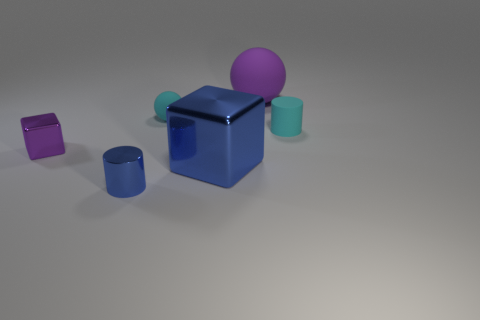Add 2 large purple matte balls. How many objects exist? 8 Subtract all blocks. How many objects are left? 4 Subtract all large blue objects. Subtract all blue matte balls. How many objects are left? 5 Add 4 tiny cyan cylinders. How many tiny cyan cylinders are left? 5 Add 2 large gray matte cubes. How many large gray matte cubes exist? 2 Subtract 0 green cylinders. How many objects are left? 6 